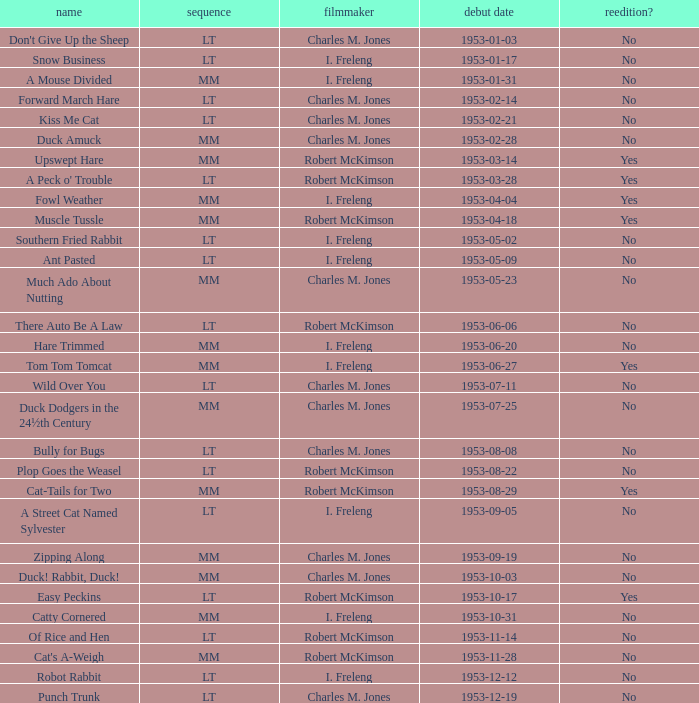What's the release date of Upswept Hare? 1953-03-14. 